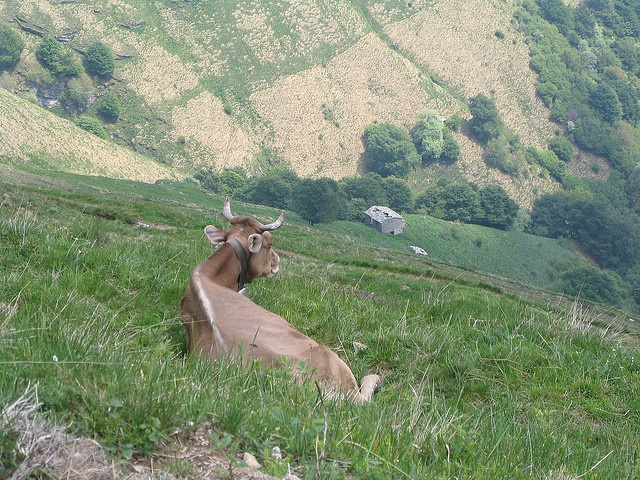Describe the objects in this image and their specific colors. I can see a cow in darkgray and gray tones in this image. 